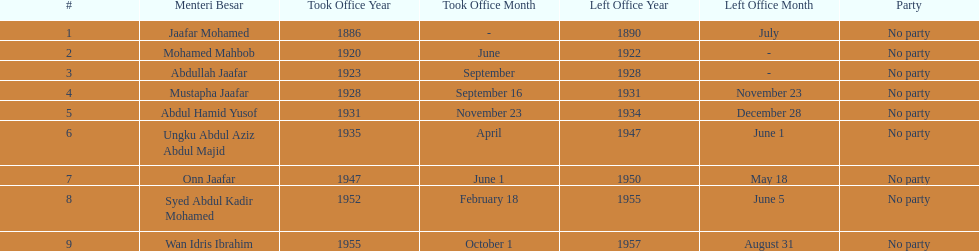Who was in office previous to abdullah jaafar? Mohamed Mahbob. 